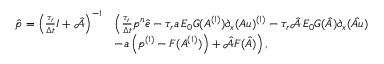Convert formula to latex. <formula><loc_0><loc_0><loc_500><loc_500>\begin{array} { r l } { \hat { p } = \left ( \frac { \tau _ { r } } { \Delta t } I + \hat { \mathcal { A } } \right ) ^ { - 1 } } & { \left ( \frac { \tau _ { r } } { \Delta t } p ^ { n } \hat { e } - \tau _ { r } a \, E _ { 0 } G ( A ^ { ( 1 ) } ) \partial _ { x } ( A u ) ^ { ( 1 ) } - \tau _ { r } \hat { \mathcal { A } } \, E _ { 0 } G ( \hat { A } ) \partial _ { x } ( \hat { A u } ) } \\ & { - a \left ( p ^ { ( 1 ) } - F ( A ^ { ( 1 ) } ) \right ) + \hat { \mathcal { A } } F ( \hat { A } ) \right ) \, , } \end{array}</formula> 